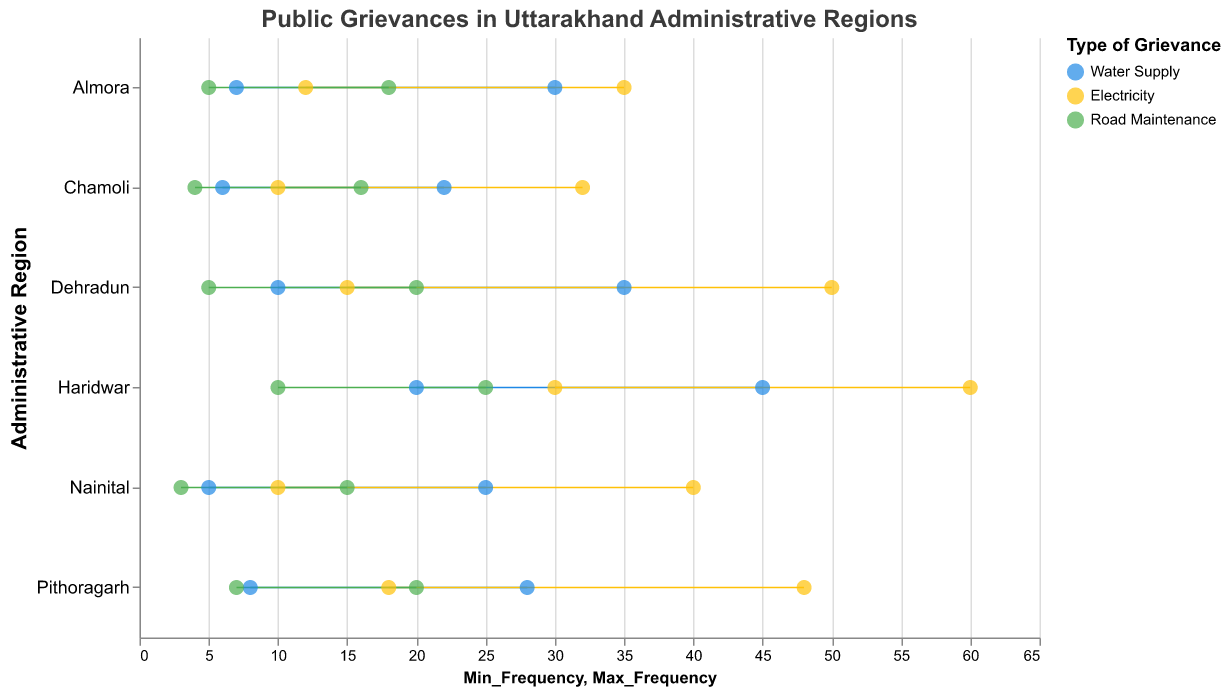What types of grievances have the highest maximum frequency in Haridwar? The types of grievances in Haridwar are Water Supply, Electricity, and Road Maintenance. Among these, Electricity has the highest maximum frequency of 60, followed by Water Supply with 45 and Road Maintenance with 25.
Answer: Electricity Which administrative region has the lowest minimum frequency for Water Supply grievances? The minimum frequencies for Water Supply grievances in the given regions are Dehradun (10), Haridwar (20), Nainital (5), Almora (7), Pithoragarh (8), and Chamoli (6). The lowest minimum frequency is in Nainital with 5.
Answer: Nainital Compare the range of frequencies for Road Maintenance grievances between Dehradun and Haridwar. Which region has a larger range? The range of frequencies for Road Maintenance grievances in Dehradun is from 5 to 20, giving a range of 15 (20-5). In Haridwar, the range is from 10 to 25, also giving a range of 15 (25-10). Both regions have the same range.
Answer: Both have the same range Which type of grievance has the widest range of frequency in Nainital? In Nainital, the frequency ranges are Water Supply (5-25), Electricity (10-40), and Road Maintenance (3-15). The width of the ranges is calculated as: Water Supply: 20 (25-5), Electricity: 30 (40-10), and Road Maintenance: 12 (15-3). The widest range is for Electricity with a range of 30.
Answer: Electricity Identify the administrative region with the highest maximum frequency for grievances overall and state that frequency. To find the administrative region with the highest maximum frequency, we need to consider the highest values among all types of grievances in each region. Dehradun's maximum values are 35, 50, and 20; Haridwar's are 45, 60, and 25; Nainital's are 25, 40, and 15; Almora's are 30, 35, and 18; Pithoragarh's are 28, 48, and 20; Chamoli's are 22, 32, and 16. Haridwar has the highest maximum frequency of 60 from Electricity grievances.
Answer: Haridwar, 60 What is the average maximum frequency for Electricity grievances across all regions? The maximum frequencies for Electricity grievances are 50 (Dehradun), 60 (Haridwar), 40 (Nainital), 35 (Almora), 48 (Pithoragarh), and 32 (Chamoli). Summing these gives 265 (50+60+40+35+48+32). There are 6 regions, so the average is 265/6 = 44.17.
Answer: 44.17 